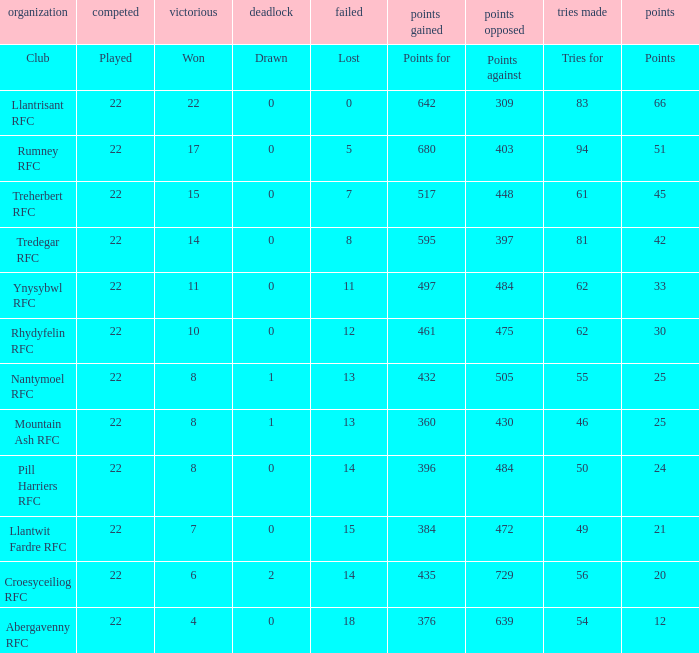For teams that won exactly 15, how many points were scored? 45.0. 